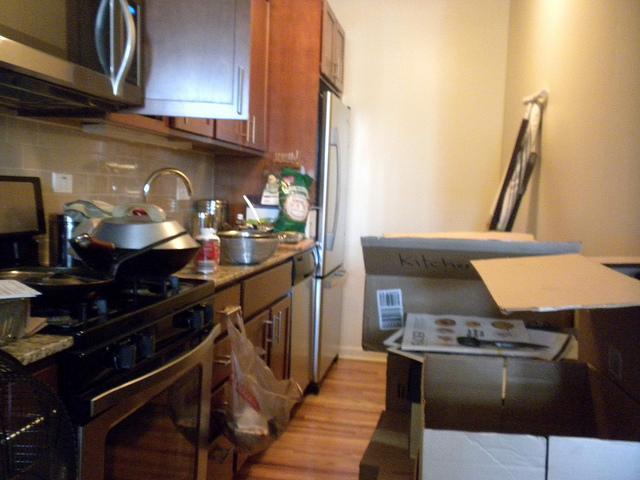What does the cardboard box tell us about this situation?
Select the correct answer and articulate reasoning with the following format: 'Answer: answer
Rationale: rationale.'
Options: Shops amazon, likes coffee, wrong room, moving in. Answer: moving in.
Rationale: A box is open and top of a counter in a kitchen. 